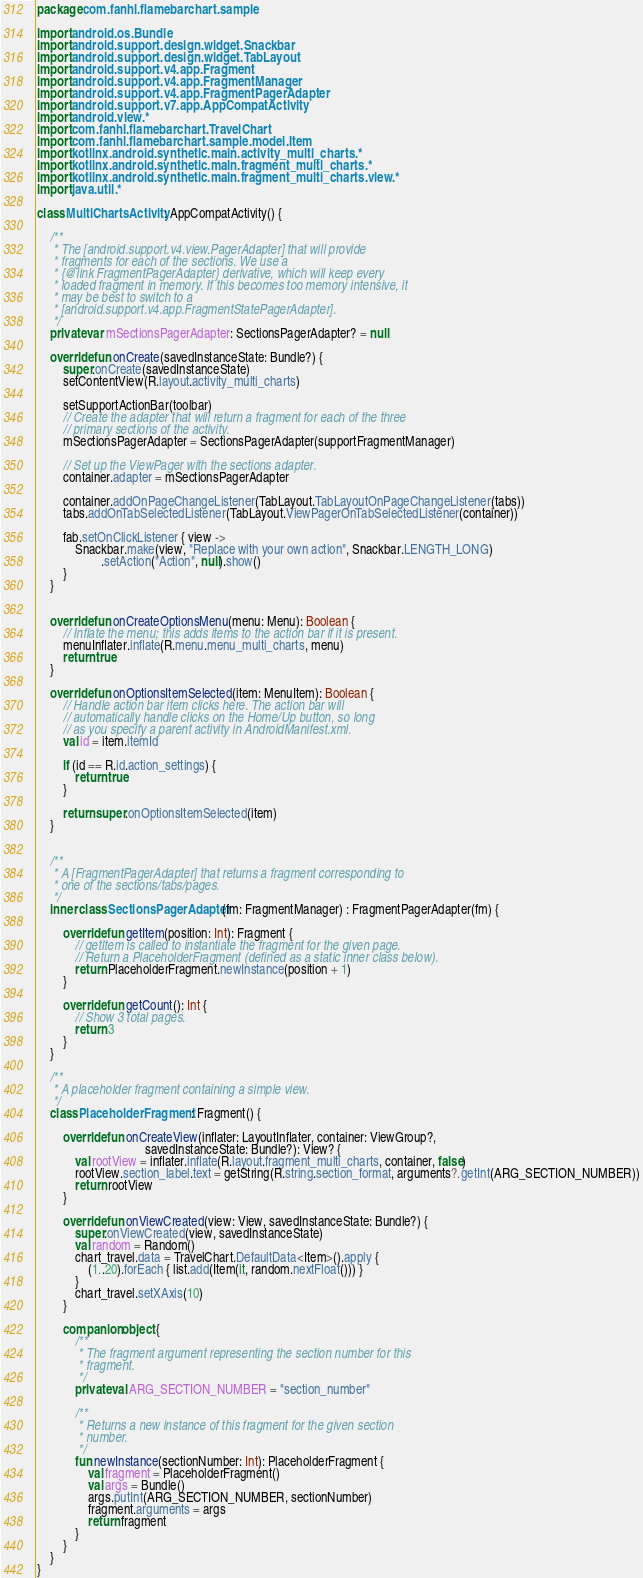<code> <loc_0><loc_0><loc_500><loc_500><_Kotlin_>package com.fanhl.flamebarchart.sample

import android.os.Bundle
import android.support.design.widget.Snackbar
import android.support.design.widget.TabLayout
import android.support.v4.app.Fragment
import android.support.v4.app.FragmentManager
import android.support.v4.app.FragmentPagerAdapter
import android.support.v7.app.AppCompatActivity
import android.view.*
import com.fanhl.flamebarchart.TravelChart
import com.fanhl.flamebarchart.sample.model.Item
import kotlinx.android.synthetic.main.activity_multi_charts.*
import kotlinx.android.synthetic.main.fragment_multi_charts.*
import kotlinx.android.synthetic.main.fragment_multi_charts.view.*
import java.util.*

class MultiChartsActivity : AppCompatActivity() {

    /**
     * The [android.support.v4.view.PagerAdapter] that will provide
     * fragments for each of the sections. We use a
     * {@link FragmentPagerAdapter} derivative, which will keep every
     * loaded fragment in memory. If this becomes too memory intensive, it
     * may be best to switch to a
     * [android.support.v4.app.FragmentStatePagerAdapter].
     */
    private var mSectionsPagerAdapter: SectionsPagerAdapter? = null

    override fun onCreate(savedInstanceState: Bundle?) {
        super.onCreate(savedInstanceState)
        setContentView(R.layout.activity_multi_charts)

        setSupportActionBar(toolbar)
        // Create the adapter that will return a fragment for each of the three
        // primary sections of the activity.
        mSectionsPagerAdapter = SectionsPagerAdapter(supportFragmentManager)

        // Set up the ViewPager with the sections adapter.
        container.adapter = mSectionsPagerAdapter

        container.addOnPageChangeListener(TabLayout.TabLayoutOnPageChangeListener(tabs))
        tabs.addOnTabSelectedListener(TabLayout.ViewPagerOnTabSelectedListener(container))

        fab.setOnClickListener { view ->
            Snackbar.make(view, "Replace with your own action", Snackbar.LENGTH_LONG)
                    .setAction("Action", null).show()
        }
    }


    override fun onCreateOptionsMenu(menu: Menu): Boolean {
        // Inflate the menu; this adds items to the action bar if it is present.
        menuInflater.inflate(R.menu.menu_multi_charts, menu)
        return true
    }

    override fun onOptionsItemSelected(item: MenuItem): Boolean {
        // Handle action bar item clicks here. The action bar will
        // automatically handle clicks on the Home/Up button, so long
        // as you specify a parent activity in AndroidManifest.xml.
        val id = item.itemId

        if (id == R.id.action_settings) {
            return true
        }

        return super.onOptionsItemSelected(item)
    }


    /**
     * A [FragmentPagerAdapter] that returns a fragment corresponding to
     * one of the sections/tabs/pages.
     */
    inner class SectionsPagerAdapter(fm: FragmentManager) : FragmentPagerAdapter(fm) {

        override fun getItem(position: Int): Fragment {
            // getItem is called to instantiate the fragment for the given page.
            // Return a PlaceholderFragment (defined as a static inner class below).
            return PlaceholderFragment.newInstance(position + 1)
        }

        override fun getCount(): Int {
            // Show 3 total pages.
            return 3
        }
    }

    /**
     * A placeholder fragment containing a simple view.
     */
    class PlaceholderFragment : Fragment() {

        override fun onCreateView(inflater: LayoutInflater, container: ViewGroup?,
                                  savedInstanceState: Bundle?): View? {
            val rootView = inflater.inflate(R.layout.fragment_multi_charts, container, false)
            rootView.section_label.text = getString(R.string.section_format, arguments?.getInt(ARG_SECTION_NUMBER))
            return rootView
        }

        override fun onViewCreated(view: View, savedInstanceState: Bundle?) {
            super.onViewCreated(view, savedInstanceState)
            val random = Random()
            chart_travel.data = TravelChart.DefaultData<Item>().apply {
                (1..20).forEach { list.add(Item(it, random.nextFloat())) }
            }
            chart_travel.setXAxis(10)
        }

        companion object {
            /**
             * The fragment argument representing the section number for this
             * fragment.
             */
            private val ARG_SECTION_NUMBER = "section_number"

            /**
             * Returns a new instance of this fragment for the given section
             * number.
             */
            fun newInstance(sectionNumber: Int): PlaceholderFragment {
                val fragment = PlaceholderFragment()
                val args = Bundle()
                args.putInt(ARG_SECTION_NUMBER, sectionNumber)
                fragment.arguments = args
                return fragment
            }
        }
    }
}
</code> 